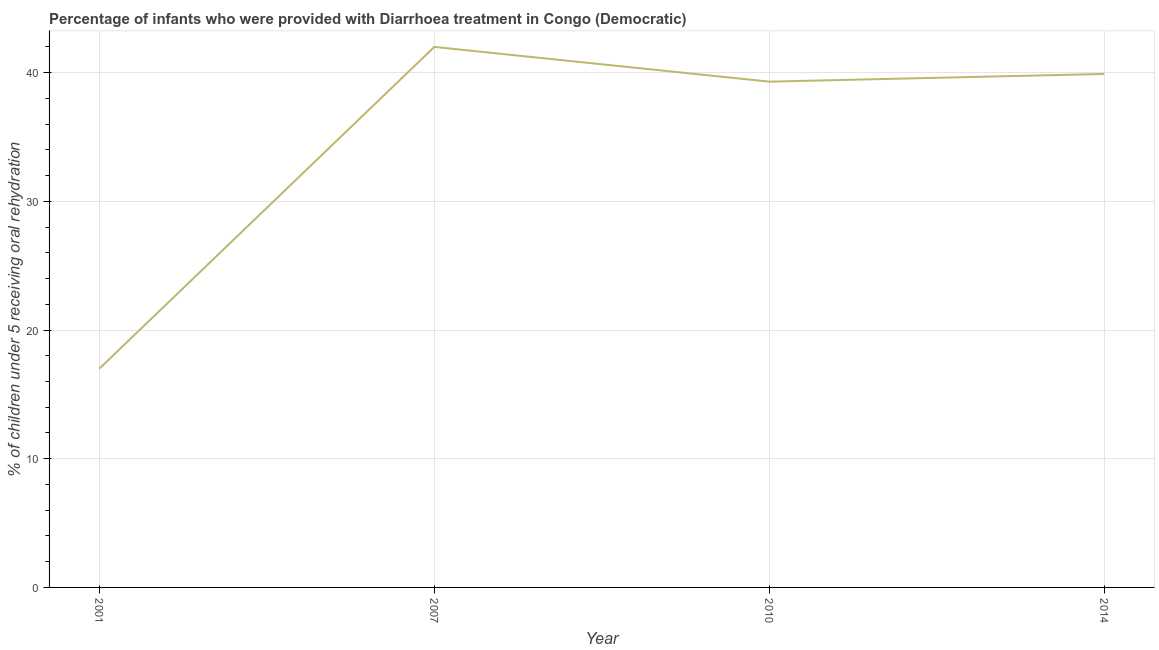What is the percentage of children who were provided with treatment diarrhoea in 2014?
Provide a short and direct response. 39.9. Across all years, what is the maximum percentage of children who were provided with treatment diarrhoea?
Provide a succinct answer. 42. Across all years, what is the minimum percentage of children who were provided with treatment diarrhoea?
Your answer should be very brief. 17. In which year was the percentage of children who were provided with treatment diarrhoea maximum?
Ensure brevity in your answer.  2007. In which year was the percentage of children who were provided with treatment diarrhoea minimum?
Provide a succinct answer. 2001. What is the sum of the percentage of children who were provided with treatment diarrhoea?
Provide a short and direct response. 138.2. What is the difference between the percentage of children who were provided with treatment diarrhoea in 2007 and 2010?
Ensure brevity in your answer.  2.7. What is the average percentage of children who were provided with treatment diarrhoea per year?
Keep it short and to the point. 34.55. What is the median percentage of children who were provided with treatment diarrhoea?
Your response must be concise. 39.6. What is the ratio of the percentage of children who were provided with treatment diarrhoea in 2001 to that in 2014?
Your response must be concise. 0.43. Is the percentage of children who were provided with treatment diarrhoea in 2010 less than that in 2014?
Provide a succinct answer. Yes. Is the difference between the percentage of children who were provided with treatment diarrhoea in 2001 and 2010 greater than the difference between any two years?
Offer a very short reply. No. What is the difference between the highest and the second highest percentage of children who were provided with treatment diarrhoea?
Offer a very short reply. 2.1. Is the sum of the percentage of children who were provided with treatment diarrhoea in 2007 and 2014 greater than the maximum percentage of children who were provided with treatment diarrhoea across all years?
Provide a succinct answer. Yes. How many lines are there?
Provide a short and direct response. 1. Does the graph contain any zero values?
Your response must be concise. No. What is the title of the graph?
Provide a succinct answer. Percentage of infants who were provided with Diarrhoea treatment in Congo (Democratic). What is the label or title of the X-axis?
Provide a short and direct response. Year. What is the label or title of the Y-axis?
Offer a very short reply. % of children under 5 receiving oral rehydration. What is the % of children under 5 receiving oral rehydration in 2010?
Offer a very short reply. 39.3. What is the % of children under 5 receiving oral rehydration of 2014?
Your response must be concise. 39.9. What is the difference between the % of children under 5 receiving oral rehydration in 2001 and 2010?
Provide a short and direct response. -22.3. What is the difference between the % of children under 5 receiving oral rehydration in 2001 and 2014?
Your answer should be very brief. -22.9. What is the difference between the % of children under 5 receiving oral rehydration in 2007 and 2010?
Provide a succinct answer. 2.7. What is the difference between the % of children under 5 receiving oral rehydration in 2010 and 2014?
Your answer should be very brief. -0.6. What is the ratio of the % of children under 5 receiving oral rehydration in 2001 to that in 2007?
Provide a short and direct response. 0.41. What is the ratio of the % of children under 5 receiving oral rehydration in 2001 to that in 2010?
Your answer should be compact. 0.43. What is the ratio of the % of children under 5 receiving oral rehydration in 2001 to that in 2014?
Offer a very short reply. 0.43. What is the ratio of the % of children under 5 receiving oral rehydration in 2007 to that in 2010?
Your response must be concise. 1.07. What is the ratio of the % of children under 5 receiving oral rehydration in 2007 to that in 2014?
Offer a terse response. 1.05. 